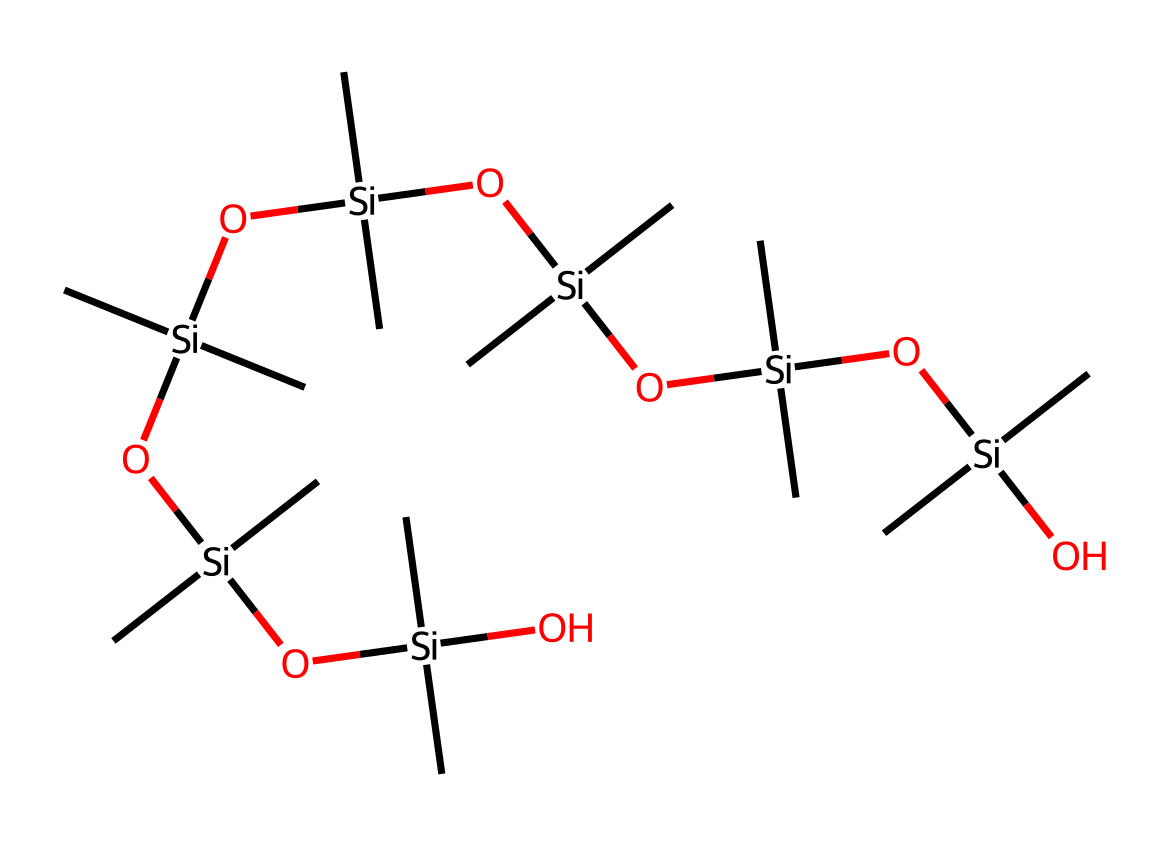What is the primary chemical element in the structure? The structure prominently features silicon atoms, which are the central elements in silicone rubber.
Answer: silicon How many silicon atoms are present in the molecule? By counting the [Si] representations in the SMILES, there are 6 silicon atoms depicted in this structure.
Answer: 6 What functional group is primarily represented in the silicone rubber structure? The presence of oxygen atoms bonded to silicon atoms indicates the inclusion of siloxane groups, which are characteristic of silicone materials.
Answer: siloxane What type of polymer is represented by this chemical structure? The chemical structure indicates it is a silicone polymer due to the alternating silicon and oxygen, forming a long-chain structure.
Answer: silicone How does the presence of both silicon and oxygen affect the material properties? The inclusion of silicon and oxygen contributes to flexibility, thermal stability, and resistance to temperature extremes, which are desirable traits in robotic applications.
Answer: flexibility and stability What is the significance of the alkyl groups in this polymer? The alkyl (methyl) groups attached to silicon enhance the polymer's hydrophobic nature, improving its compatibility with various surfaces and reducing stickiness.
Answer: hydrophobic nature How many oxygen atoms are found in the structure? Counting the [O] representations in the SMILES shows that there are 5 oxygen atoms in the chemical structure.
Answer: 5 